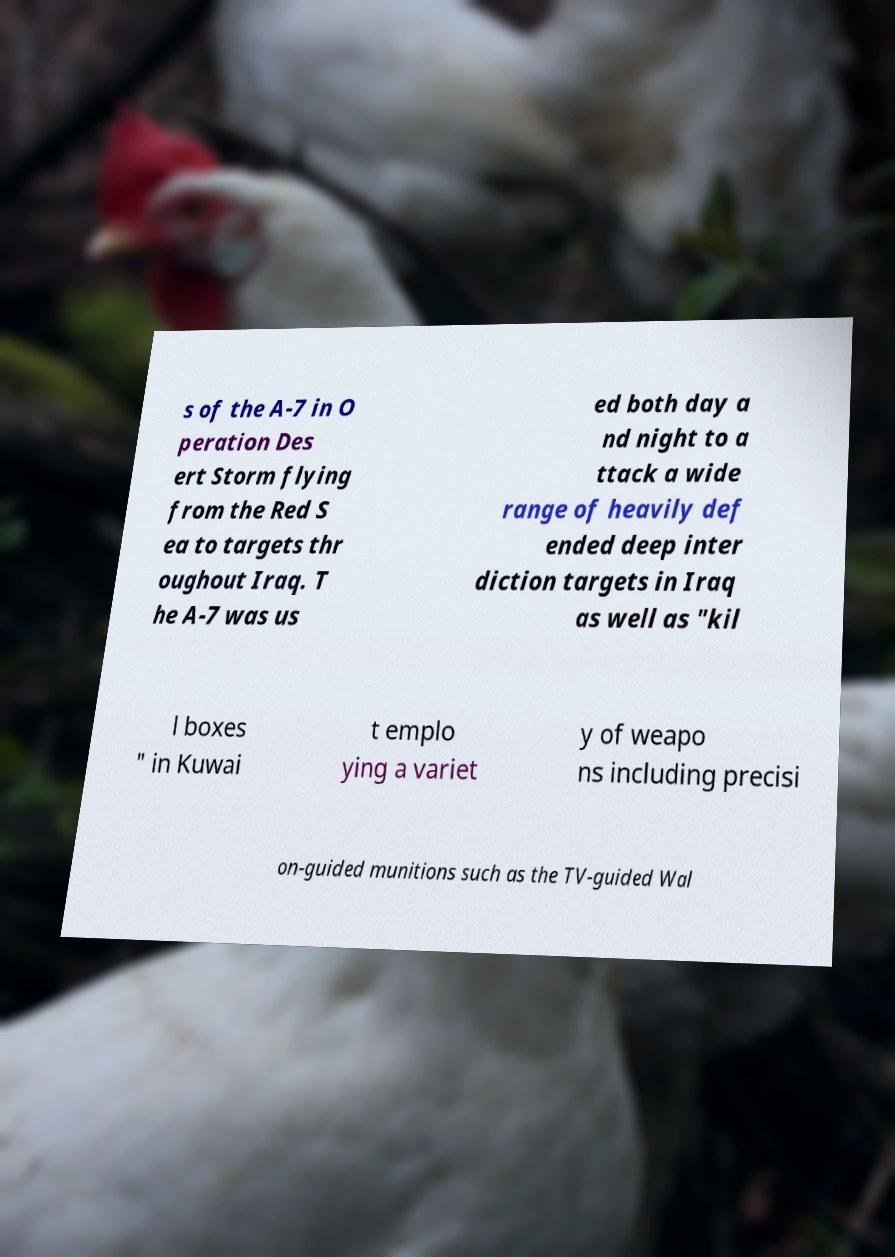Could you assist in decoding the text presented in this image and type it out clearly? s of the A-7 in O peration Des ert Storm flying from the Red S ea to targets thr oughout Iraq. T he A-7 was us ed both day a nd night to a ttack a wide range of heavily def ended deep inter diction targets in Iraq as well as "kil l boxes " in Kuwai t emplo ying a variet y of weapo ns including precisi on-guided munitions such as the TV-guided Wal 